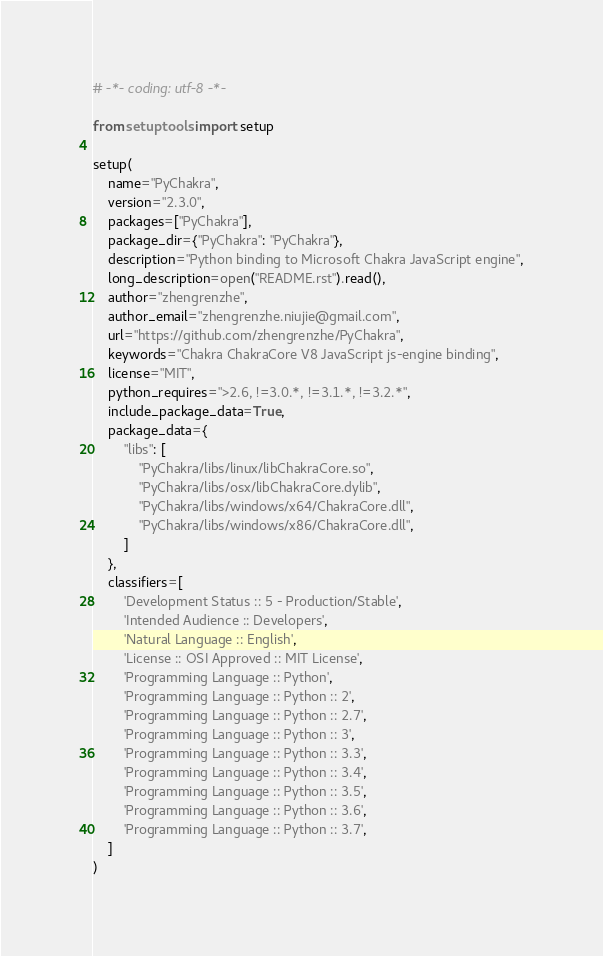Convert code to text. <code><loc_0><loc_0><loc_500><loc_500><_Python_># -*- coding: utf-8 -*-

from setuptools import setup

setup(
    name="PyChakra",
    version="2.3.0",
    packages=["PyChakra"],
    package_dir={"PyChakra": "PyChakra"},
    description="Python binding to Microsoft Chakra JavaScript engine",
    long_description=open("README.rst").read(),
    author="zhengrenzhe",
    author_email="zhengrenzhe.niujie@gmail.com",
    url="https://github.com/zhengrenzhe/PyChakra",
    keywords="Chakra ChakraCore V8 JavaScript js-engine binding",
    license="MIT",
    python_requires=">2.6, !=3.0.*, !=3.1.*, !=3.2.*",
    include_package_data=True,
    package_data={
        "libs": [
            "PyChakra/libs/linux/libChakraCore.so",
            "PyChakra/libs/osx/libChakraCore.dylib",
            "PyChakra/libs/windows/x64/ChakraCore.dll",
            "PyChakra/libs/windows/x86/ChakraCore.dll",
        ]
    },
    classifiers=[
        'Development Status :: 5 - Production/Stable',
        'Intended Audience :: Developers',
        'Natural Language :: English',
        'License :: OSI Approved :: MIT License',
        'Programming Language :: Python',
        'Programming Language :: Python :: 2',
        'Programming Language :: Python :: 2.7',
        'Programming Language :: Python :: 3',
        'Programming Language :: Python :: 3.3',
        'Programming Language :: Python :: 3.4',
        'Programming Language :: Python :: 3.5',
        'Programming Language :: Python :: 3.6',
        'Programming Language :: Python :: 3.7',
    ]
)
</code> 